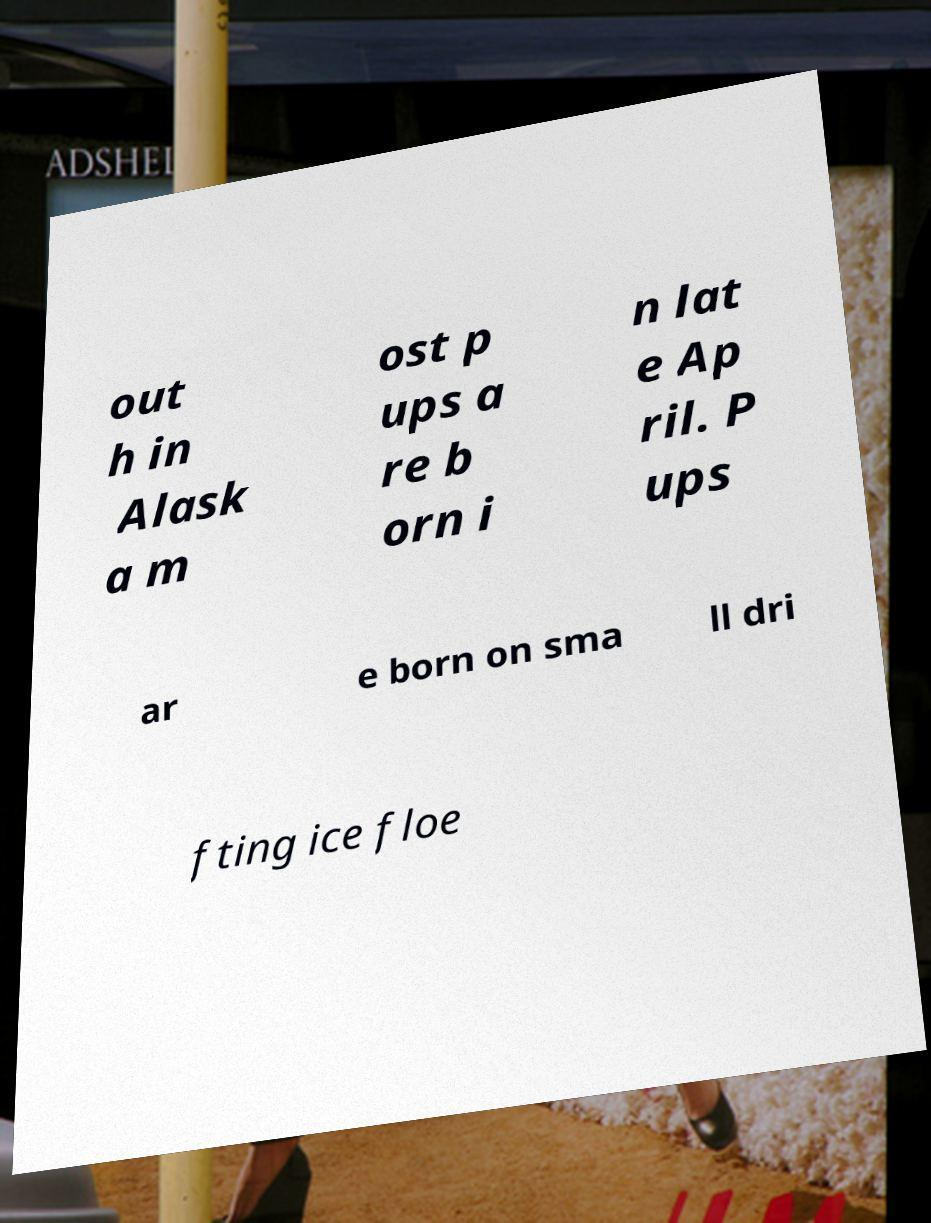Could you extract and type out the text from this image? out h in Alask a m ost p ups a re b orn i n lat e Ap ril. P ups ar e born on sma ll dri fting ice floe 